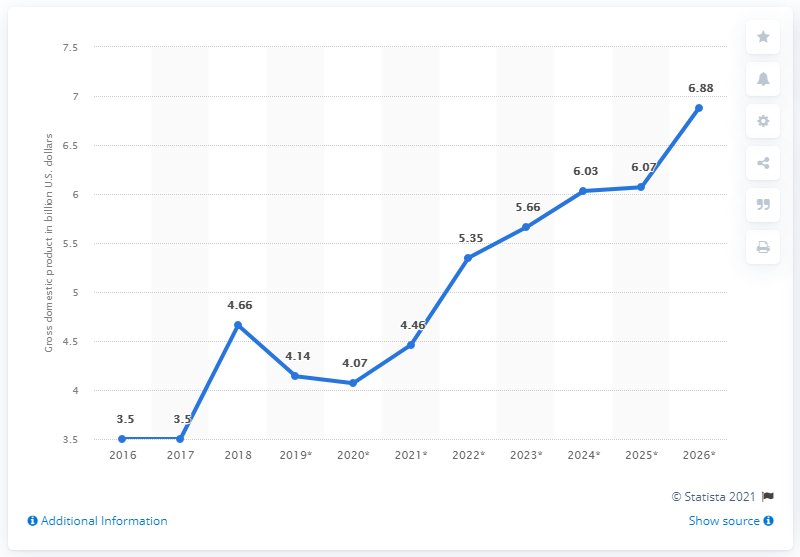Give some essential details in this illustration. South Sudan's gross domestic product in dollars was approximately 4.66 billion dollars in 2018. 